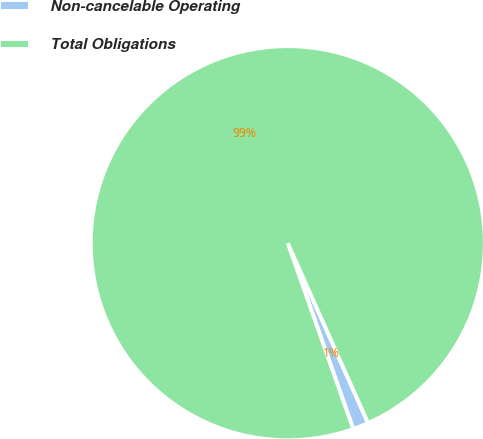<chart> <loc_0><loc_0><loc_500><loc_500><pie_chart><fcel>Non-cancelable Operating<fcel>Total Obligations<nl><fcel>1.29%<fcel>98.71%<nl></chart> 